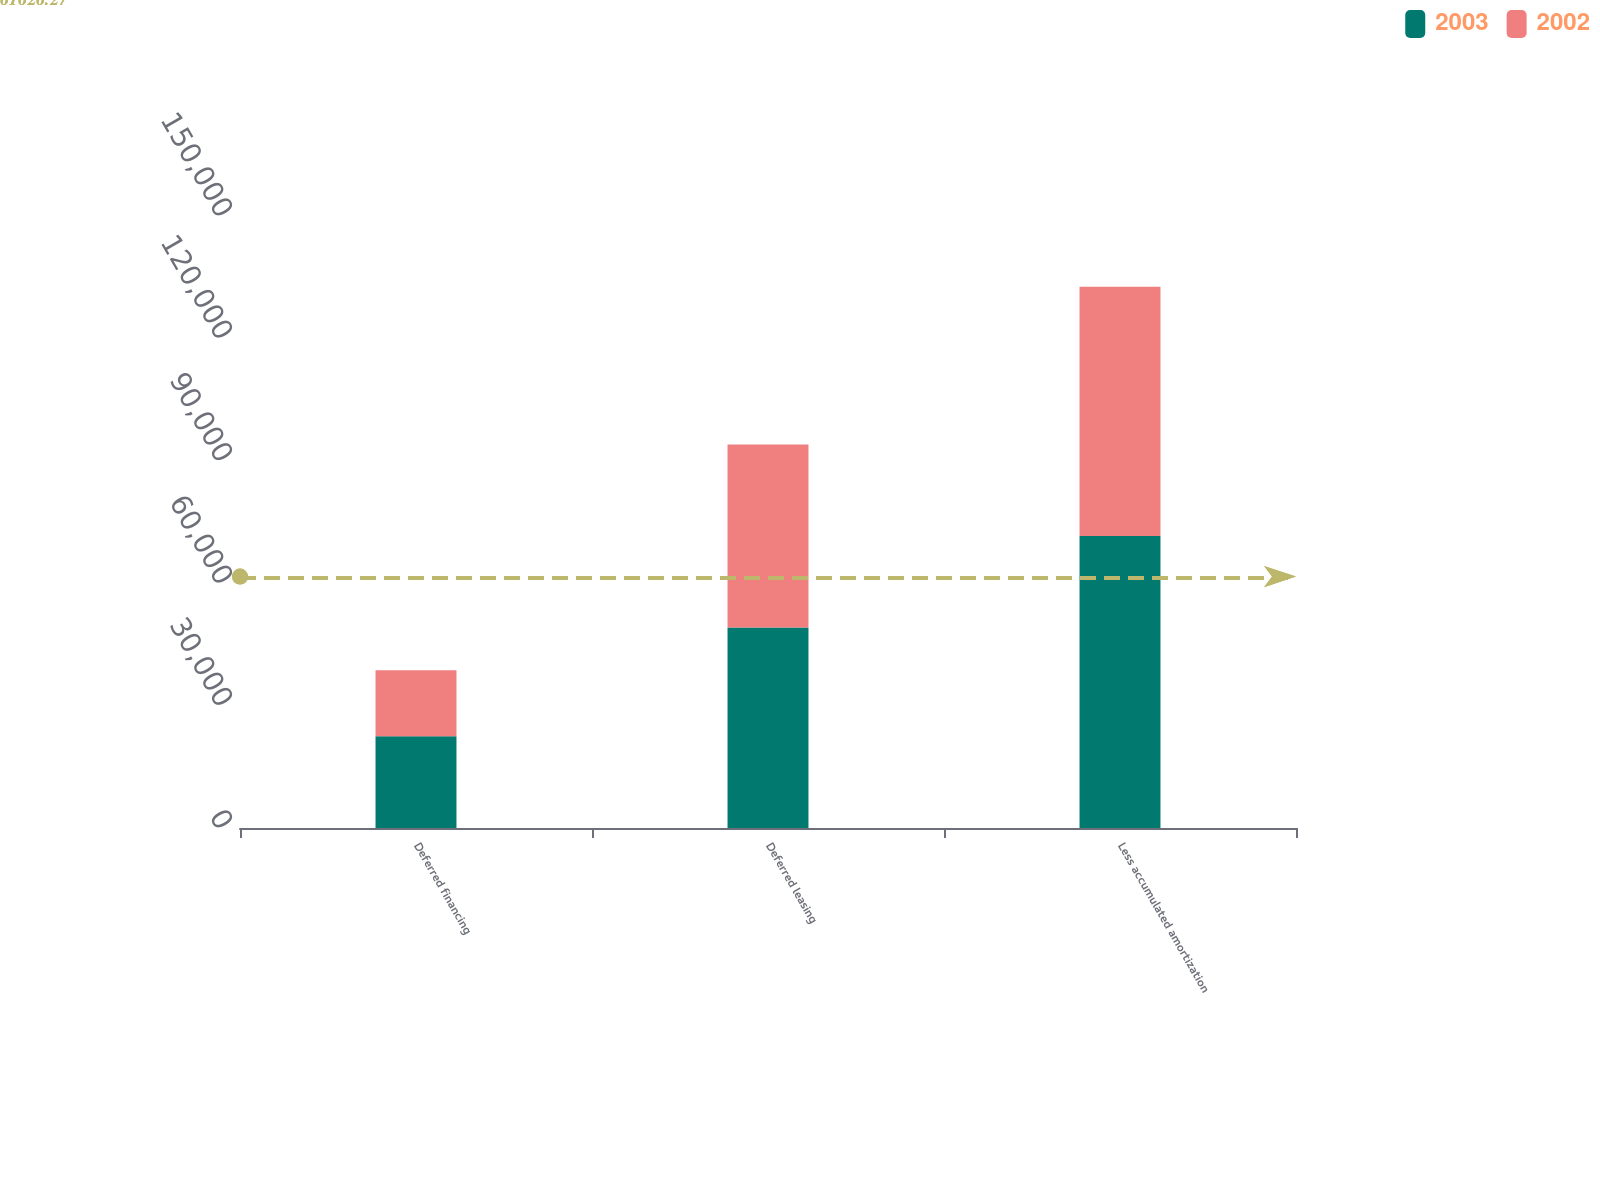Convert chart. <chart><loc_0><loc_0><loc_500><loc_500><stacked_bar_chart><ecel><fcel>Deferred financing<fcel>Deferred leasing<fcel>Less accumulated amortization<nl><fcel>2003<fcel>22464<fcel>49131<fcel>71595<nl><fcel>2002<fcel>16180<fcel>44881<fcel>61061<nl></chart> 